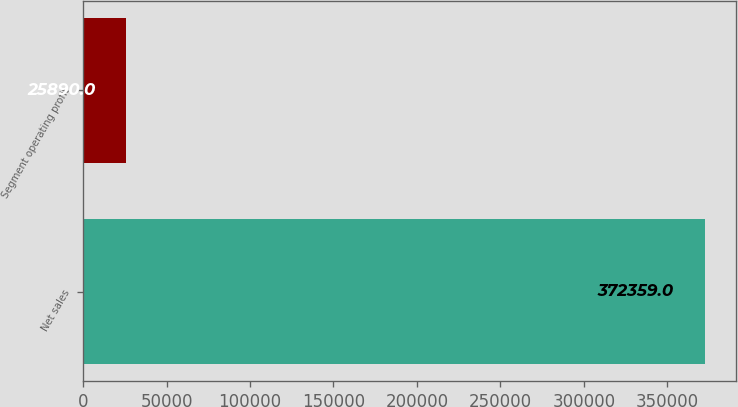Convert chart to OTSL. <chart><loc_0><loc_0><loc_500><loc_500><bar_chart><fcel>Net sales<fcel>Segment operating profit<nl><fcel>372359<fcel>25890<nl></chart> 